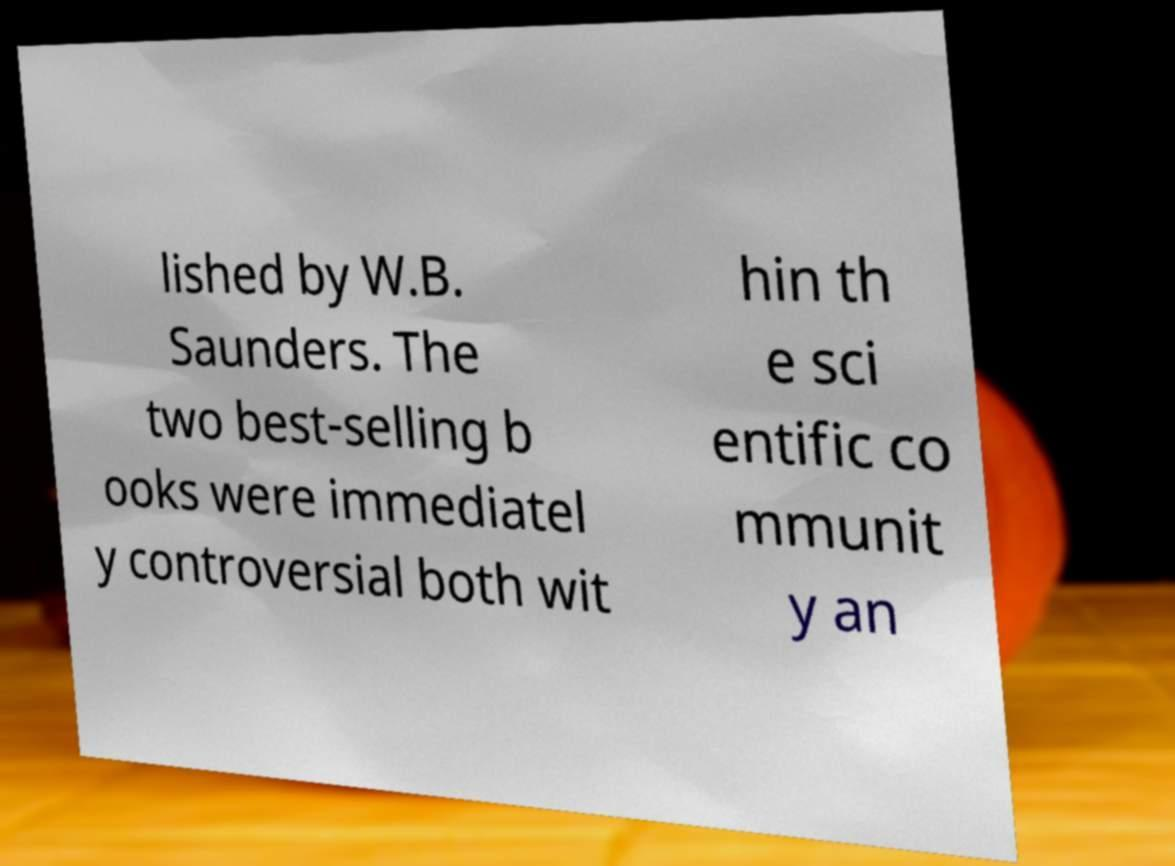Can you read and provide the text displayed in the image?This photo seems to have some interesting text. Can you extract and type it out for me? lished by W.B. Saunders. The two best-selling b ooks were immediatel y controversial both wit hin th e sci entific co mmunit y an 